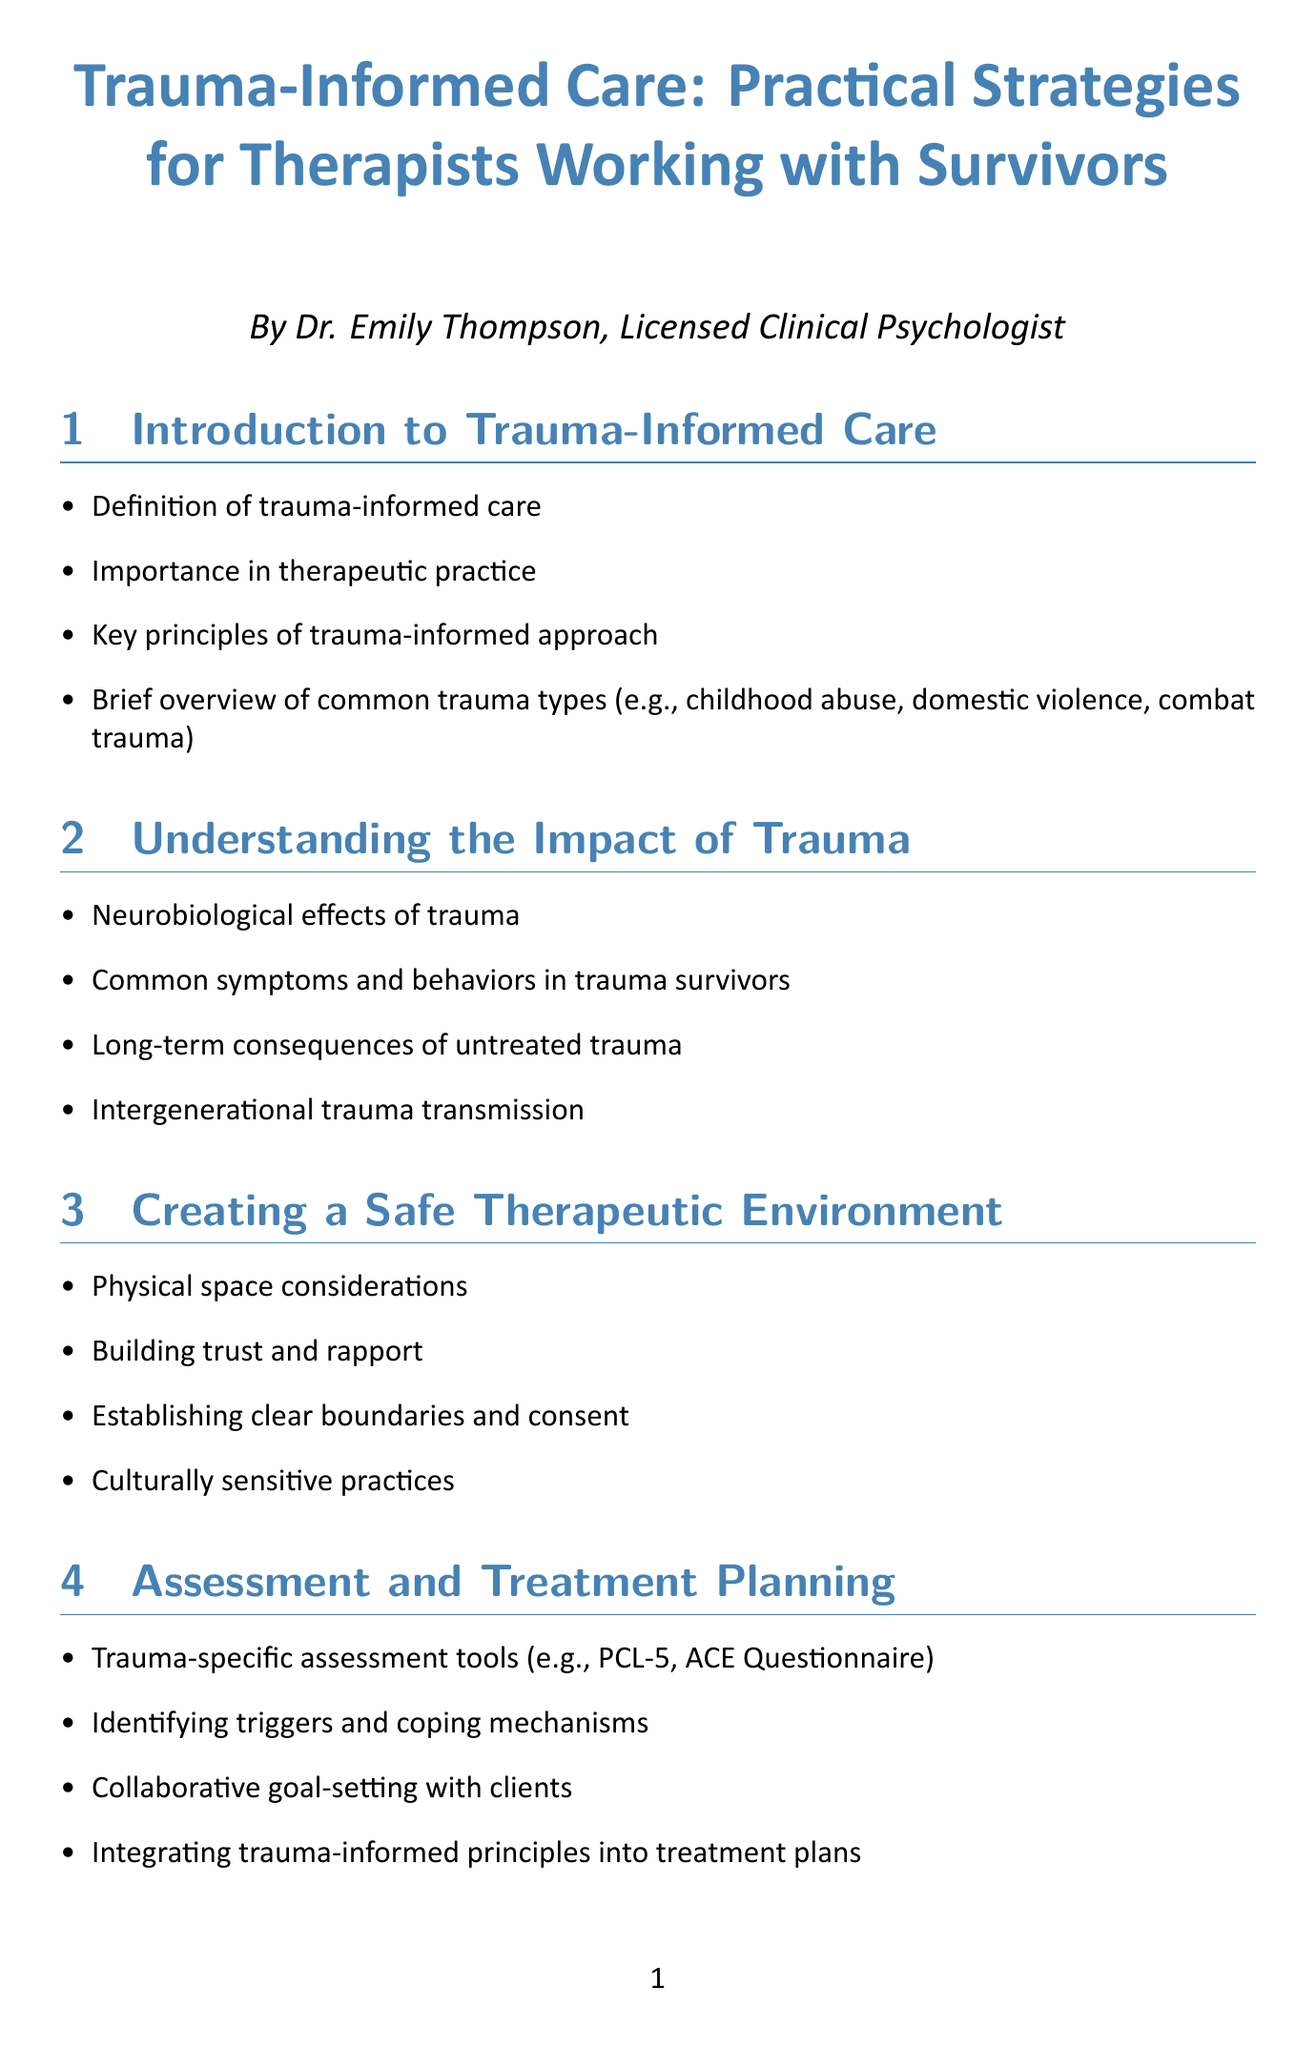What is the title of the manual? The title of the manual is stated prominently at the beginning of the document.
Answer: Trauma-Informed Care: Practical Strategies for Therapists Working with Survivors Who is the author of the manual? The author is mentioned below the title to provide credit for the content.
Answer: Dr. Emily Thompson, Licensed Clinical Psychologist What is one key principle of trauma-informed care? Key principles are listed in the introduction section of the document.
Answer: Building trust and rapport Which therapy is abbreviated as TF-CBT? The abbreviation is explained in the section discussing evidence-based interventions.
Answer: Trauma-Focused Cognitive Behavioral Therapy What should therapists prioritize according to practical tips? The practical tips section highlights important considerations for therapists.
Answer: Client safety and comfort How many case studies are included in the manual? The document lists case studies in the respective section.
Answer: Four What type of trauma involves veterans? The section discussing specific populations outlines various trauma types.
Answer: Combat trauma What is a recommended technique for managing anxiety? The practical techniques for emotional regulation section includes various techniques.
Answer: Breathing techniques for anxiety management What type of support is advised for therapists to seek? The self-care section highlights important aspects of therapist wellness.
Answer: Supervision and peer support 